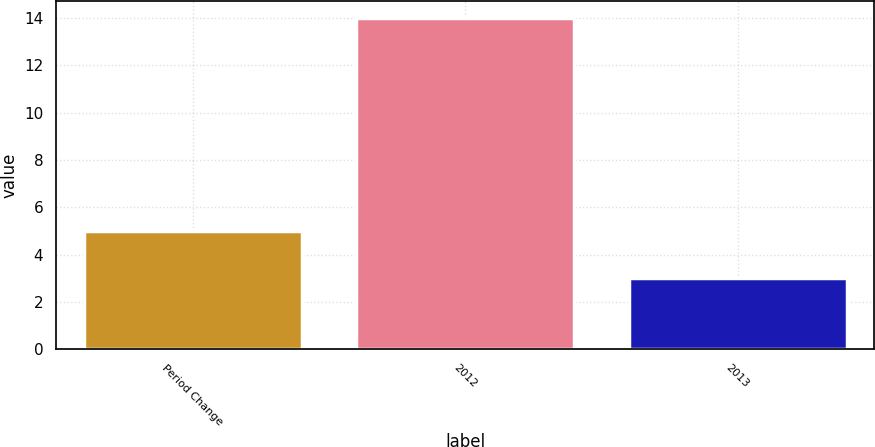Convert chart. <chart><loc_0><loc_0><loc_500><loc_500><bar_chart><fcel>Period Change<fcel>2012<fcel>2013<nl><fcel>5<fcel>14<fcel>3<nl></chart> 